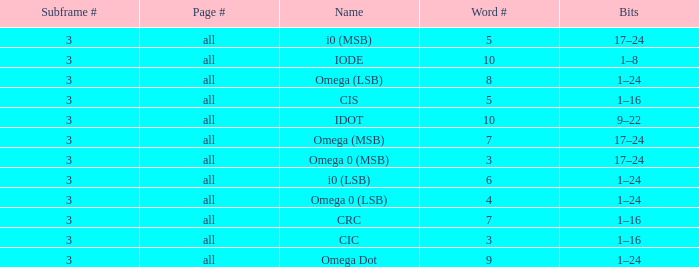What is the total word count with a subframe count greater than 3? None. 